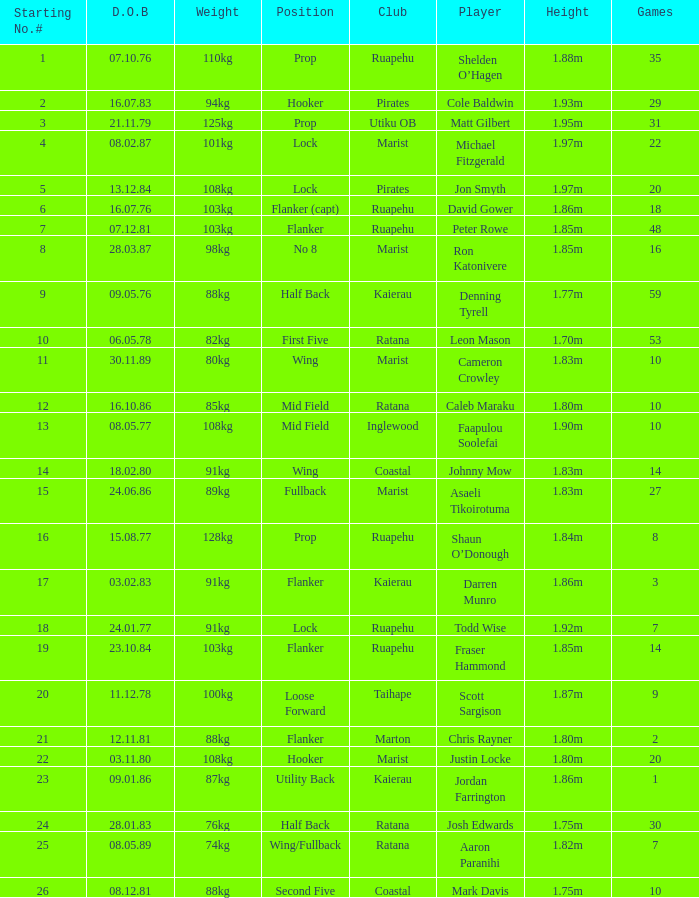Which player weighs 76kg? Josh Edwards. 